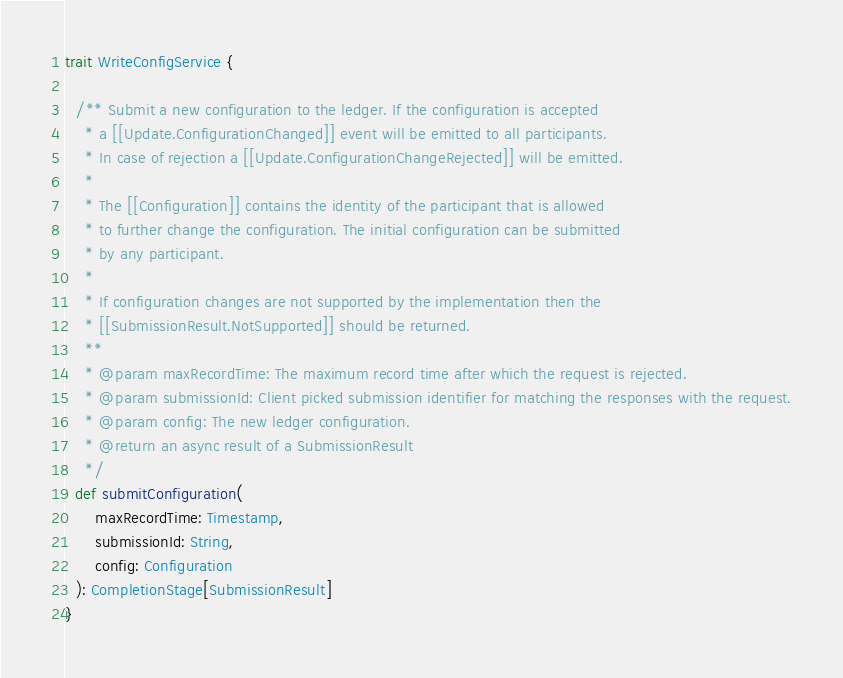<code> <loc_0><loc_0><loc_500><loc_500><_Scala_>trait WriteConfigService {

  /** Submit a new configuration to the ledger. If the configuration is accepted
    * a [[Update.ConfigurationChanged]] event will be emitted to all participants.
    * In case of rejection a [[Update.ConfigurationChangeRejected]] will be emitted.
    *
    * The [[Configuration]] contains the identity of the participant that is allowed
    * to further change the configuration. The initial configuration can be submitted
    * by any participant.
    *
    * If configuration changes are not supported by the implementation then the
    * [[SubmissionResult.NotSupported]] should be returned.
    **
    * @param maxRecordTime: The maximum record time after which the request is rejected.
    * @param submissionId: Client picked submission identifier for matching the responses with the request.
    * @param config: The new ledger configuration.
    * @return an async result of a SubmissionResult
    */
  def submitConfiguration(
      maxRecordTime: Timestamp,
      submissionId: String,
      config: Configuration
  ): CompletionStage[SubmissionResult]
}
</code> 